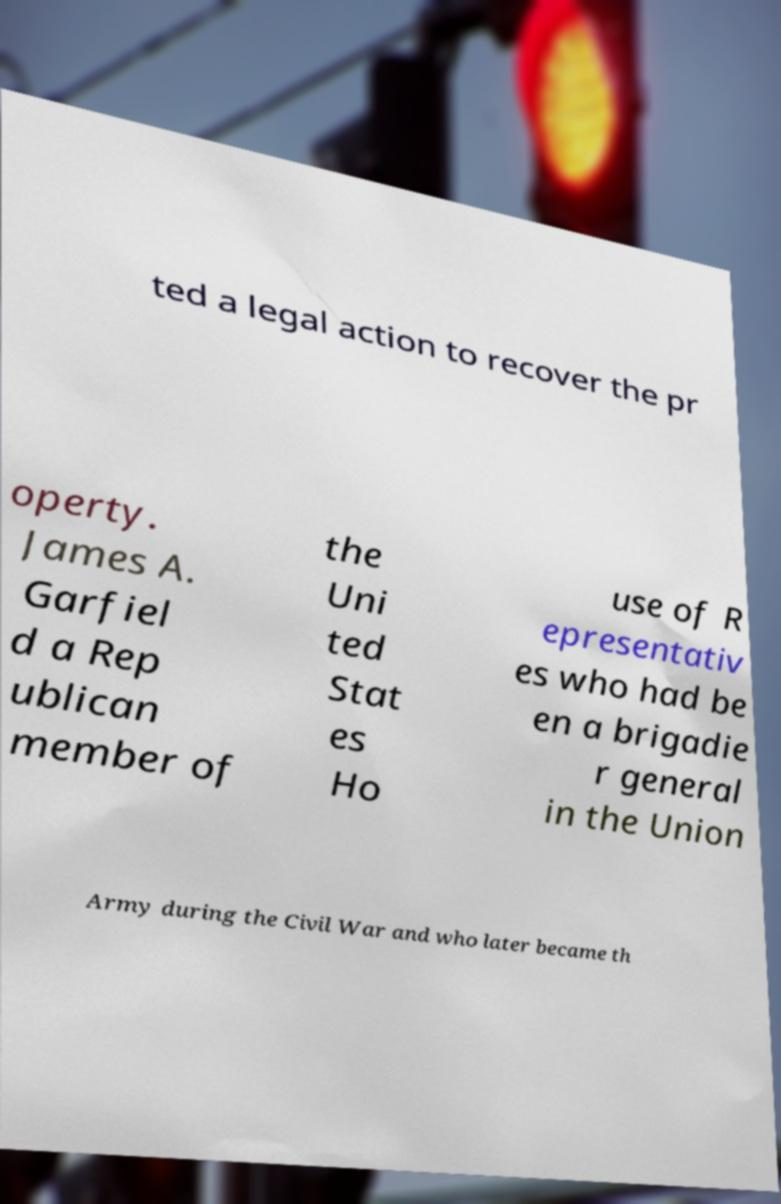Could you assist in decoding the text presented in this image and type it out clearly? ted a legal action to recover the pr operty. James A. Garfiel d a Rep ublican member of the Uni ted Stat es Ho use of R epresentativ es who had be en a brigadie r general in the Union Army during the Civil War and who later became th 